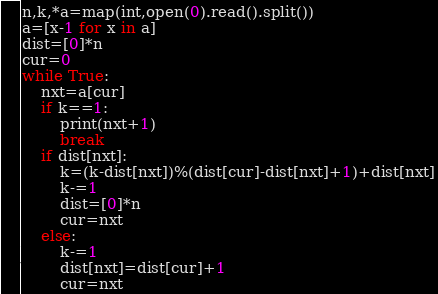<code> <loc_0><loc_0><loc_500><loc_500><_Python_>n,k,*a=map(int,open(0).read().split())
a=[x-1 for x in a]
dist=[0]*n
cur=0
while True:
	nxt=a[cur]
	if k==1:
		print(nxt+1)
		break
	if dist[nxt]:
		k=(k-dist[nxt])%(dist[cur]-dist[nxt]+1)+dist[nxt]
		k-=1
		dist=[0]*n
		cur=nxt
	else:
		k-=1
		dist[nxt]=dist[cur]+1
		cur=nxt</code> 